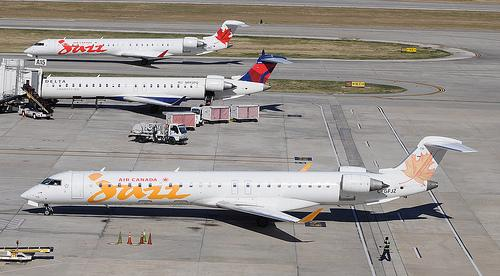What is the color and shape of the logo on the side of the plane? The logo is an orange maple leaf. Count the total number of airplanes in the image. There are three airplanes in the image. Are there any people visible in the image? If so, what are they doing? Yes, a group of people is standing next to the plane, a man is walking towards the plane, and a man is working at the airport. Give a short, descriptive overview of the entire image. The image captures a busy airport scene where three planes are parked on the ground, with people and various vehicles, including cargo trucks and luggage carriers, interacting on the tarmac. What sentiments or emotions can be inferred from the image? The image conveys a sense of activity, productivity, and travel-related excitement. What type of sign is seen on the runway? A yellow runway marker sign is seen on the runway. In a brief statement, describe the scene taking place at the airport. At the airport, three planes are parked on the ground while people, luggage trucks, and other vehicles bustle around on the tarmac. What type of vehicle is seen between two planes in the image? An airport cargo truck is seen between two planes. Analyze the image in terms of its quality or clarity. The image has clear and detailed information about the objects within it, allowing for a comprehensive understanding and analysis of the airport scene. Identify the different objects related to the white airplane in the image. Logo, windshield, engine, wing, red logo, yellow words, wings, window, glass, wheel, shadow, edge of a wing, and part of a plane. 